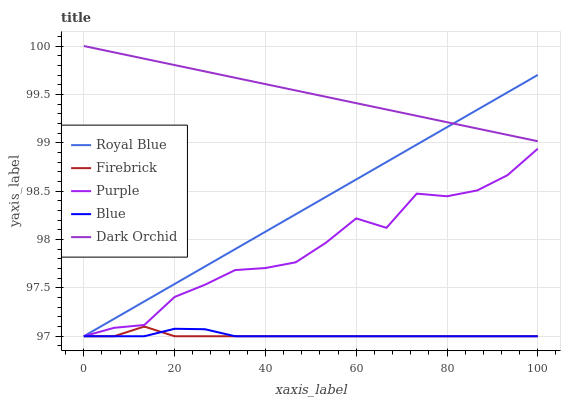Does Royal Blue have the minimum area under the curve?
Answer yes or no. No. Does Royal Blue have the maximum area under the curve?
Answer yes or no. No. Is Firebrick the smoothest?
Answer yes or no. No. Is Firebrick the roughest?
Answer yes or no. No. Does Dark Orchid have the lowest value?
Answer yes or no. No. Does Royal Blue have the highest value?
Answer yes or no. No. Is Firebrick less than Dark Orchid?
Answer yes or no. Yes. Is Dark Orchid greater than Blue?
Answer yes or no. Yes. Does Firebrick intersect Dark Orchid?
Answer yes or no. No. 